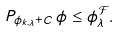<formula> <loc_0><loc_0><loc_500><loc_500>P _ { \phi _ { k , \lambda } + C } \, \phi \leq \phi _ { \lambda } ^ { \mathcal { F } } .</formula> 